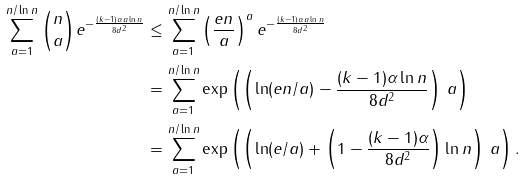<formula> <loc_0><loc_0><loc_500><loc_500>\sum _ { a = 1 } ^ { n / \ln { n } } \binom { n } { a } e ^ { - \frac { ( k - 1 ) \alpha a \ln { n } } { 8 d ^ { 2 } } } & \leq \sum _ { a = 1 } ^ { n / \ln { n } } \left ( \frac { e n } { a } \right ) ^ { a } e ^ { - \frac { ( k - 1 ) \alpha a \ln { n } } { 8 d ^ { 2 } } } \\ & = \sum _ { a = 1 } ^ { n / \ln { n } } \exp \left ( \left ( \ln ( e n / a ) - \frac { ( k - 1 ) \alpha \ln { n } } { 8 d ^ { 2 } } \right ) \, a \right ) \\ & = \sum _ { a = 1 } ^ { n / \ln { n } } \exp \left ( \left ( \ln ( e / a ) + \left ( 1 - \frac { ( k - 1 ) \alpha } { 8 d ^ { 2 } } \right ) \ln { n } \right ) \, a \right ) .</formula> 